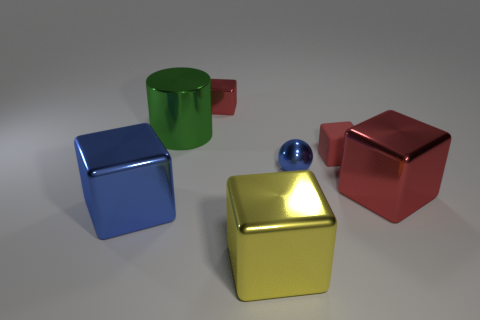Subtract all gray spheres. How many red blocks are left? 3 Subtract all red shiny cubes. How many cubes are left? 3 Subtract 1 blocks. How many blocks are left? 4 Subtract all yellow blocks. How many blocks are left? 4 Add 1 tiny red shiny blocks. How many objects exist? 8 Subtract all purple blocks. Subtract all gray balls. How many blocks are left? 5 Subtract all blocks. How many objects are left? 2 Subtract 0 purple cylinders. How many objects are left? 7 Subtract all blue matte blocks. Subtract all rubber blocks. How many objects are left? 6 Add 4 spheres. How many spheres are left? 5 